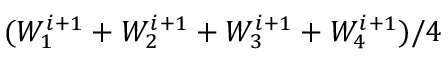Convert formula to latex. <formula><loc_0><loc_0><loc_500><loc_500>( W _ { 1 } ^ { i + 1 } + W _ { 2 } ^ { i + 1 } + W _ { 3 } ^ { i + 1 } + W _ { 4 } ^ { i + 1 } ) / 4</formula> 